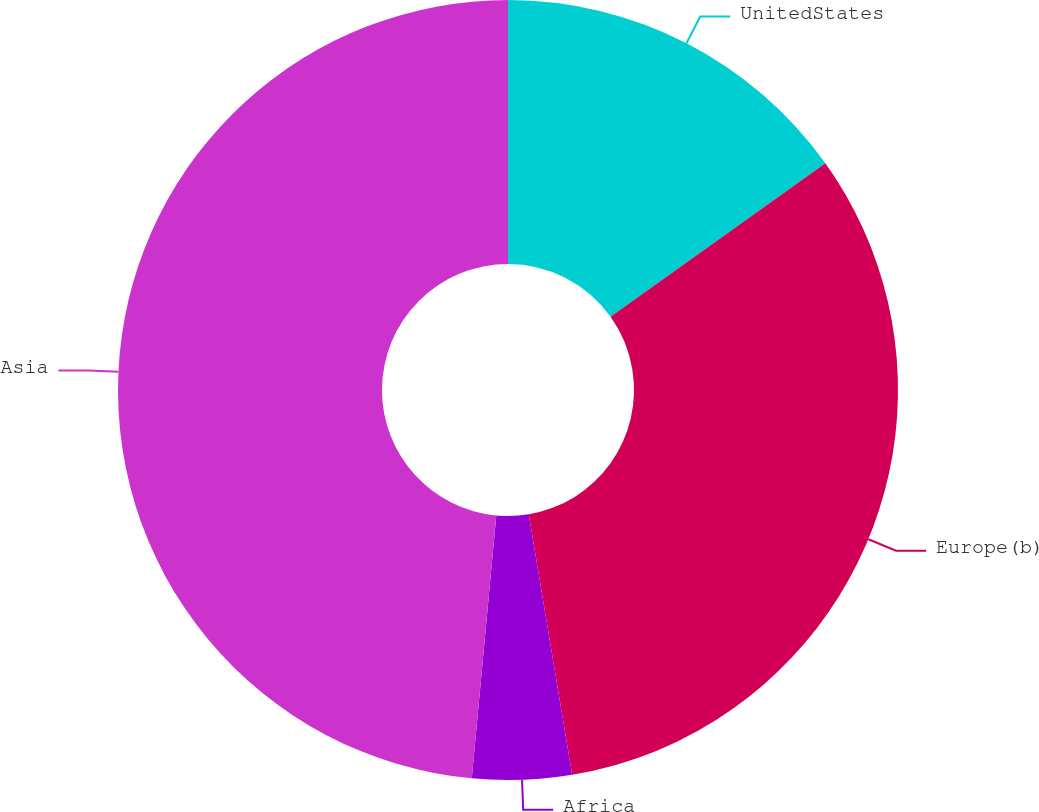Convert chart. <chart><loc_0><loc_0><loc_500><loc_500><pie_chart><fcel>UnitedStates<fcel>Europe(b)<fcel>Africa<fcel>Asia<nl><fcel>15.13%<fcel>32.24%<fcel>4.11%<fcel>48.52%<nl></chart> 